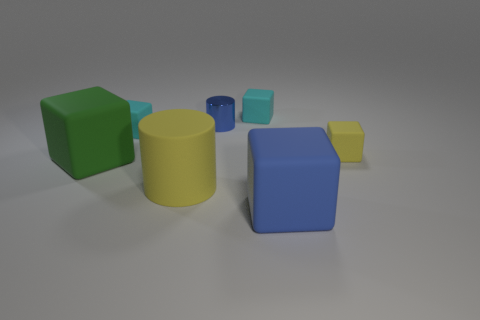Subtract 2 blocks. How many blocks are left? 3 Subtract all blue blocks. How many blocks are left? 4 Subtract all small yellow cubes. How many cubes are left? 4 Subtract all red cubes. Subtract all blue cylinders. How many cubes are left? 5 Add 2 rubber objects. How many objects exist? 9 Subtract all cylinders. How many objects are left? 5 Add 4 large green matte things. How many large green matte things exist? 5 Subtract 0 gray cylinders. How many objects are left? 7 Subtract all tiny blue matte blocks. Subtract all big things. How many objects are left? 4 Add 2 large matte objects. How many large matte objects are left? 5 